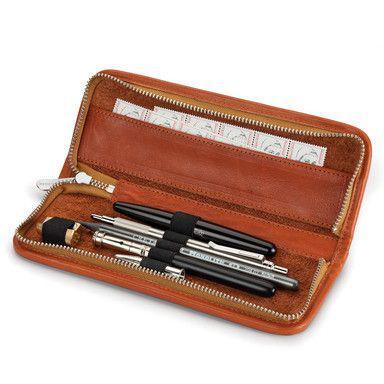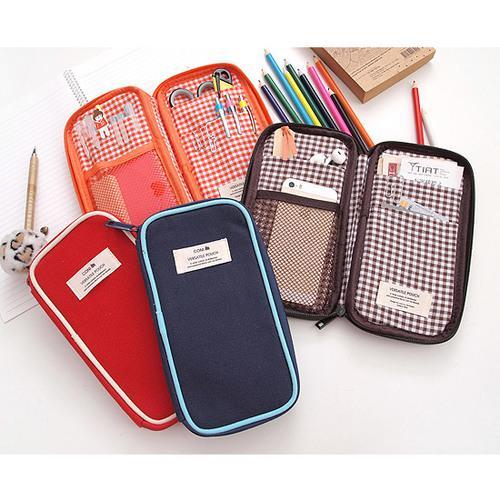The first image is the image on the left, the second image is the image on the right. Considering the images on both sides, is "There is an image of a single closed case and an image showing both the closed and open case." valid? Answer yes or no. No. 